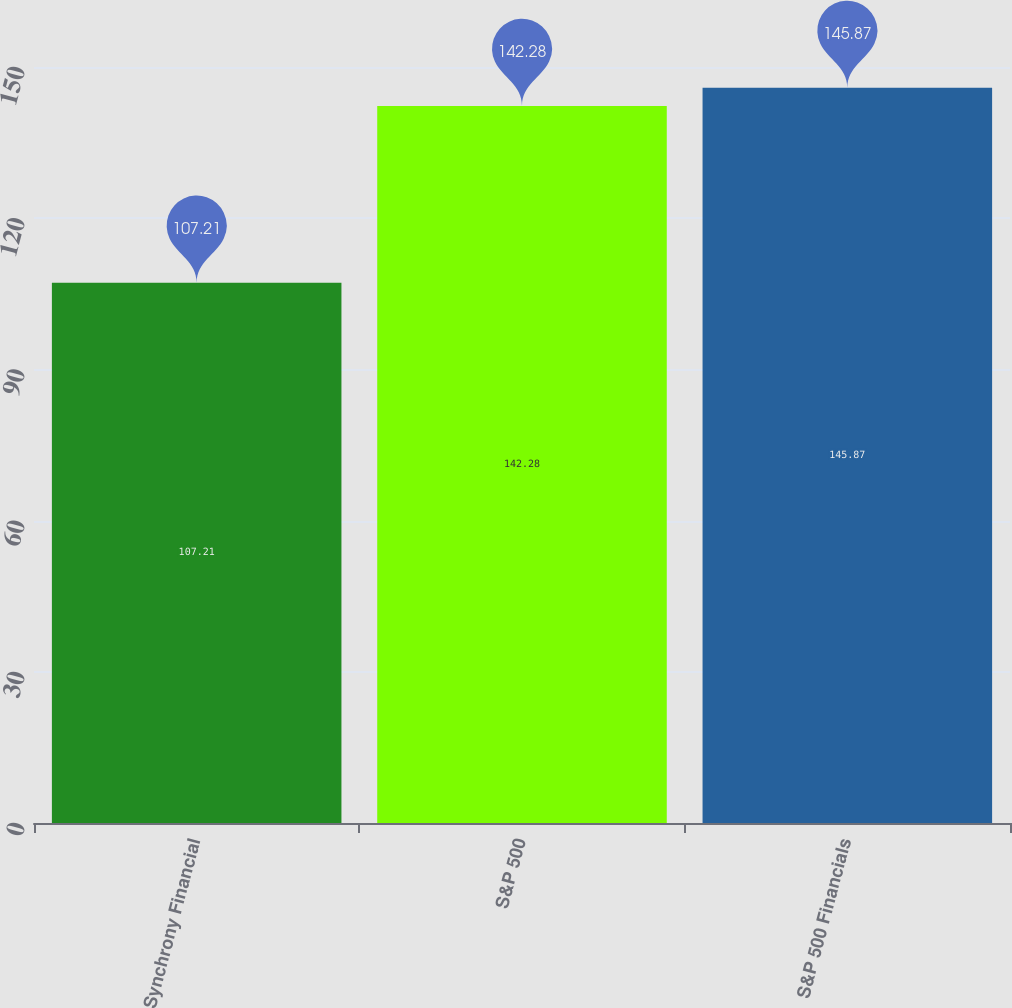Convert chart. <chart><loc_0><loc_0><loc_500><loc_500><bar_chart><fcel>Synchrony Financial<fcel>S&P 500<fcel>S&P 500 Financials<nl><fcel>107.21<fcel>142.28<fcel>145.87<nl></chart> 